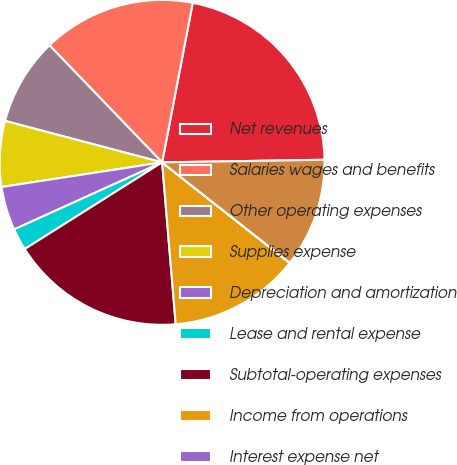Convert chart. <chart><loc_0><loc_0><loc_500><loc_500><pie_chart><fcel>Net revenues<fcel>Salaries wages and benefits<fcel>Other operating expenses<fcel>Supplies expense<fcel>Depreciation and amortization<fcel>Lease and rental expense<fcel>Subtotal-operating expenses<fcel>Income from operations<fcel>Interest expense net<fcel>Income before income taxes<nl><fcel>21.73%<fcel>15.21%<fcel>8.7%<fcel>6.53%<fcel>4.35%<fcel>2.18%<fcel>17.38%<fcel>13.04%<fcel>0.01%<fcel>10.87%<nl></chart> 